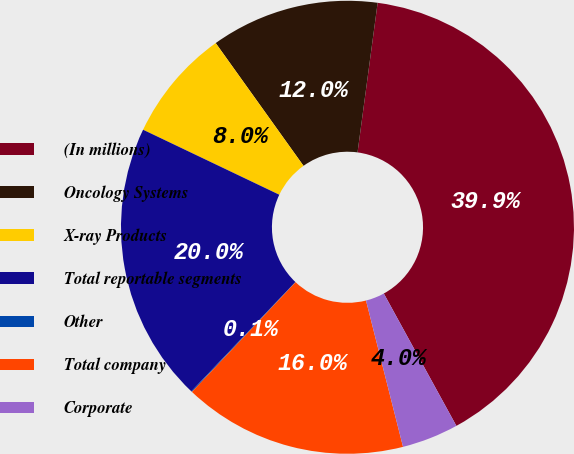Convert chart. <chart><loc_0><loc_0><loc_500><loc_500><pie_chart><fcel>(In millions)<fcel>Oncology Systems<fcel>X-ray Products<fcel>Total reportable segments<fcel>Other<fcel>Total company<fcel>Corporate<nl><fcel>39.89%<fcel>12.01%<fcel>8.03%<fcel>19.98%<fcel>0.06%<fcel>15.99%<fcel>4.04%<nl></chart> 